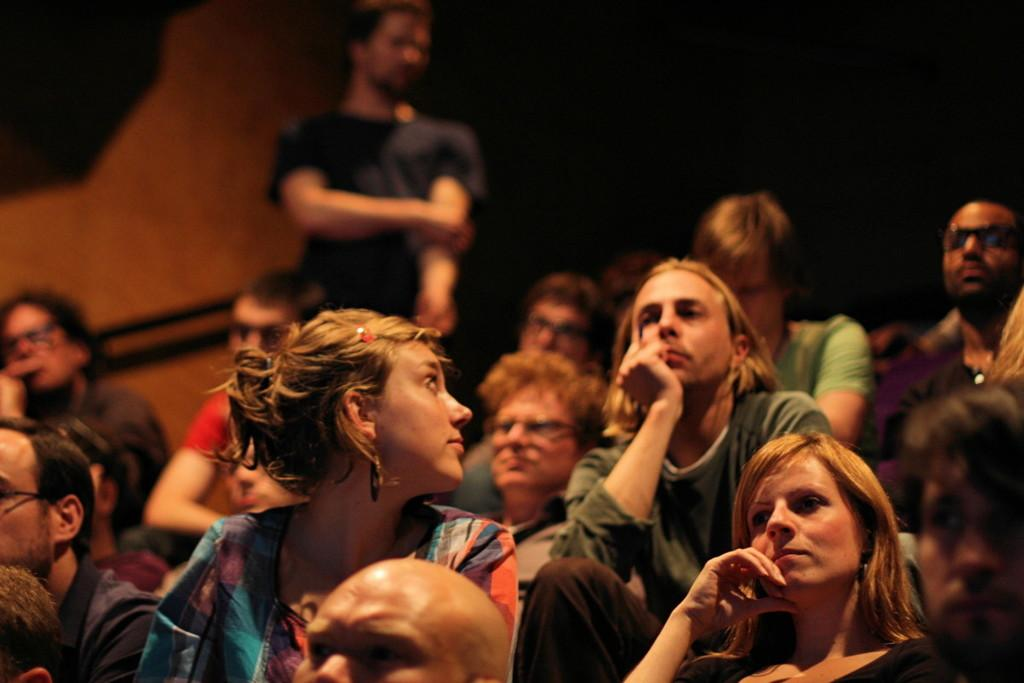How many people are in the image? There are persons in the image, but the exact number is not specified. What are the persons wearing? The persons are wearing clothes. Can you describe the background of the image? The background of the image is blurred. Can you see a window in the image? There is no mention of a window in the image. 